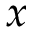Convert formula to latex. <formula><loc_0><loc_0><loc_500><loc_500>x</formula> 